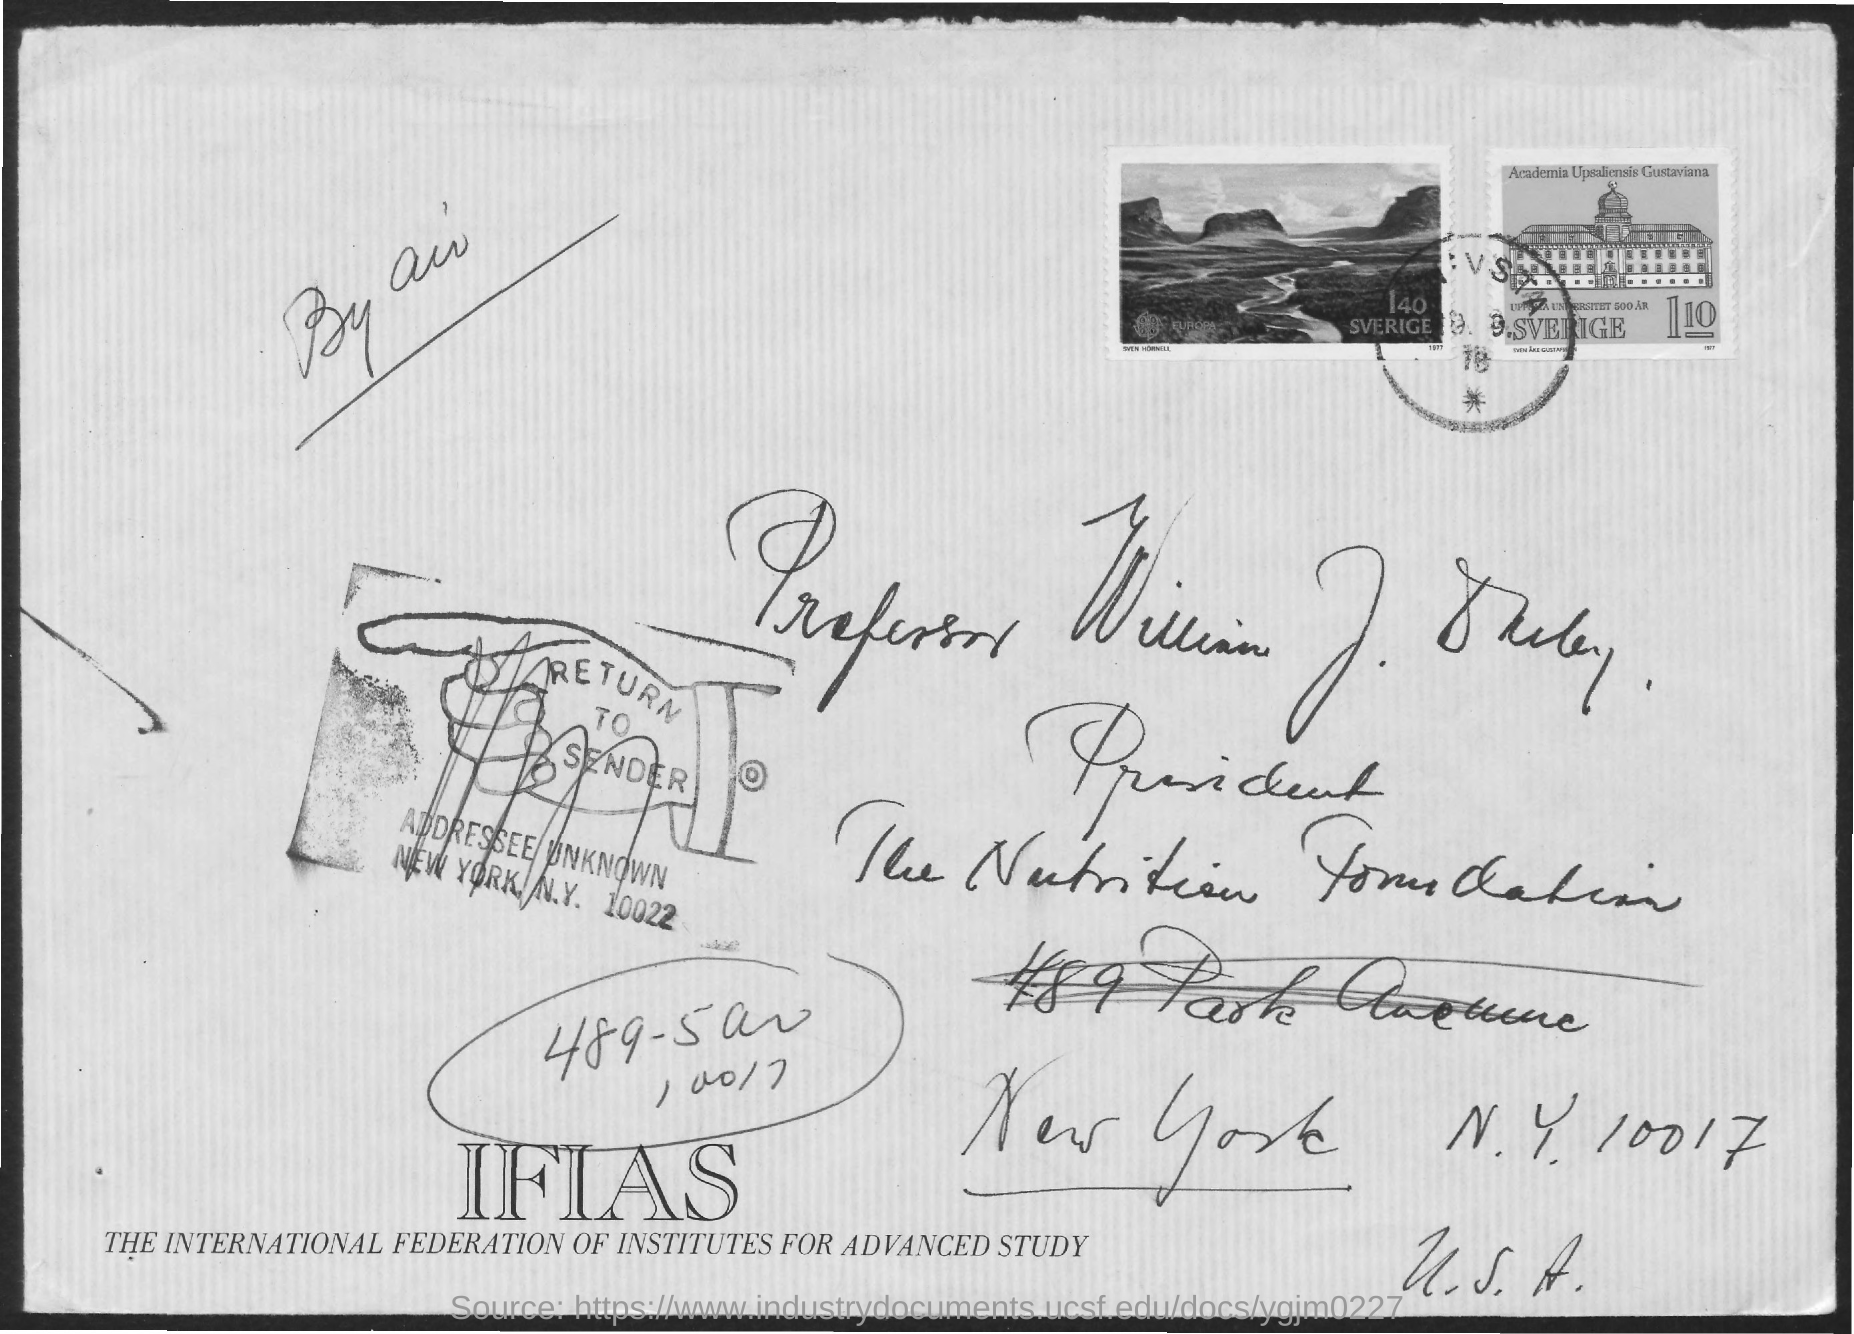What is IFIAS stands for?
Your answer should be very brief. THE INTERNATIONAL FEDERATION OF INSTITUTES FOR ADVANCED STUDY. How was the envelope posted?
Offer a terse response. BY AIR. Who is the envelope addressed to?
Make the answer very short. PROFESSOR WILLIAM J. DARBY. What was the post mentioned?
Your answer should be compact. PRESIDENT. What is the zipcode specified?
Offer a very short reply. 10017. 